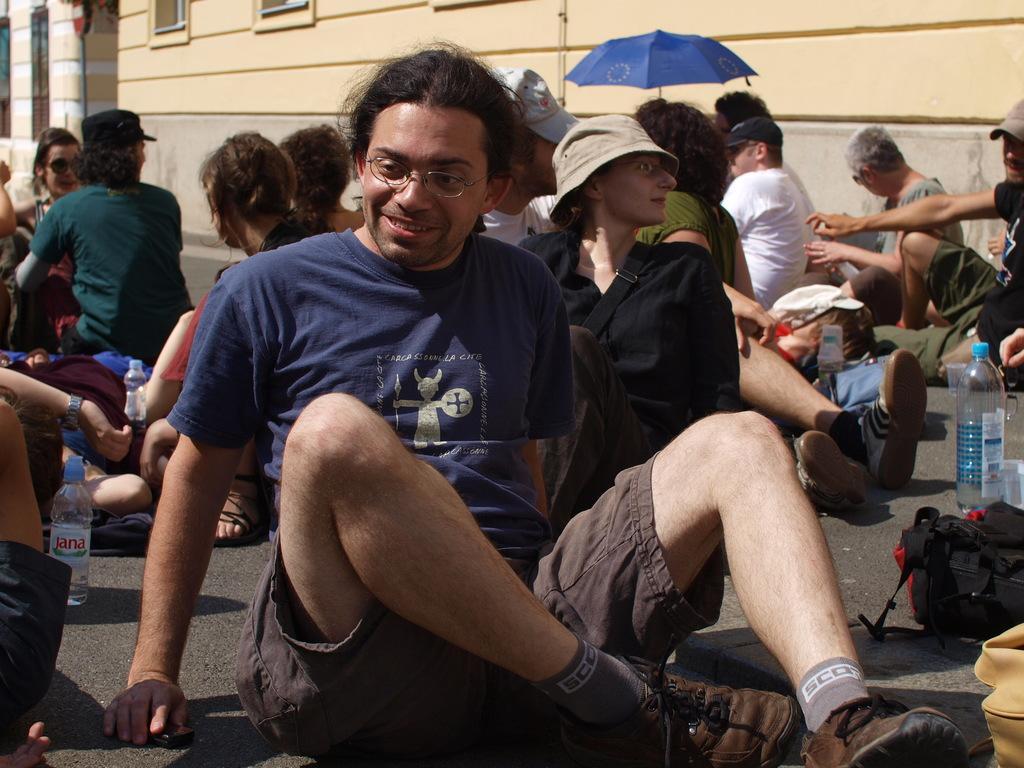Could you give a brief overview of what you see in this image? In the image there are many people sitting on road on a sunny day, in the back there are buildings, the man in the front wore violet t-shirt and brown shorts. 